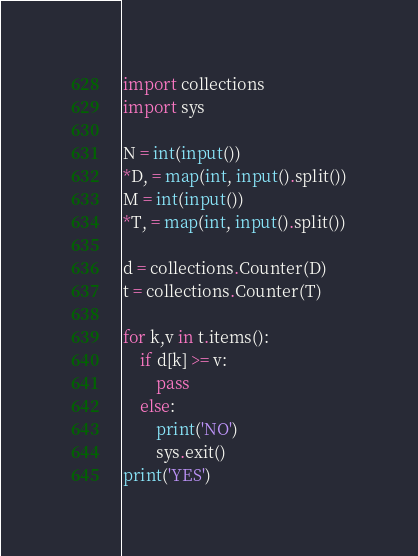<code> <loc_0><loc_0><loc_500><loc_500><_Python_>import collections
import sys

N = int(input())
*D, = map(int, input().split())
M = int(input())
*T, = map(int, input().split())

d = collections.Counter(D)
t = collections.Counter(T)

for k,v in t.items():
    if d[k] >= v:
        pass
    else:
        print('NO')
        sys.exit()
print('YES')</code> 